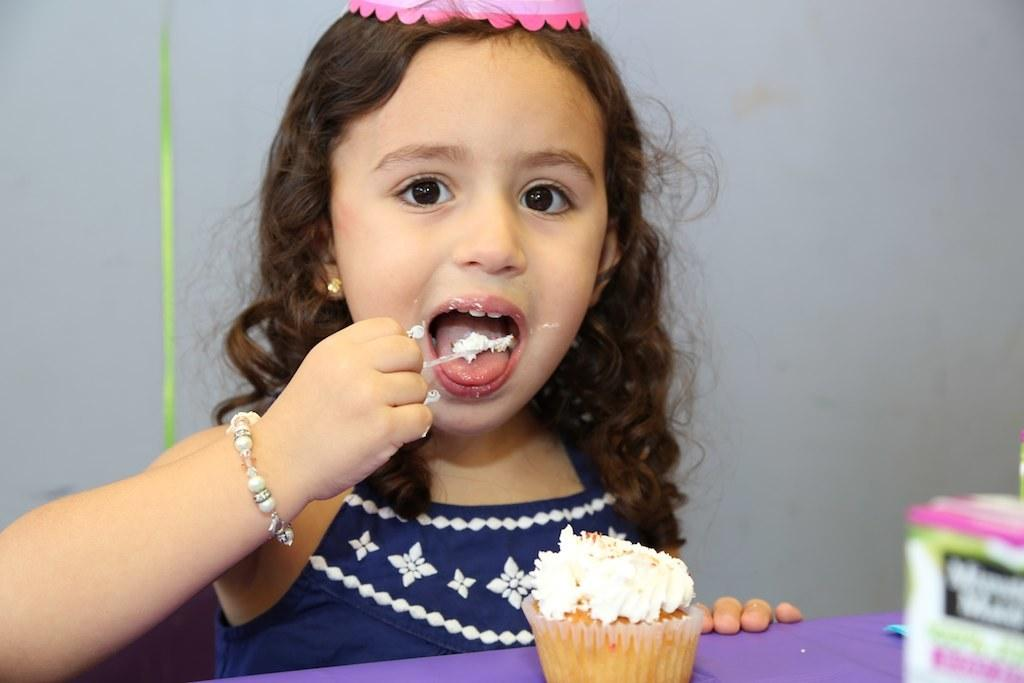Who is the main subject in the image? There is a girl in the image. What is the girl doing in the image? The girl is sitting and eating cake. Can you describe the object in the image? Unfortunately, the facts provided do not give any details about the object in the image. What is the color of the background in the image? The background of the image is white. What type of advertisement can be seen in the image? There is no advertisement present in the image. How is the girl flying the kite in the image? There is no kite present in the image; the girl is eating cake while sitting. 